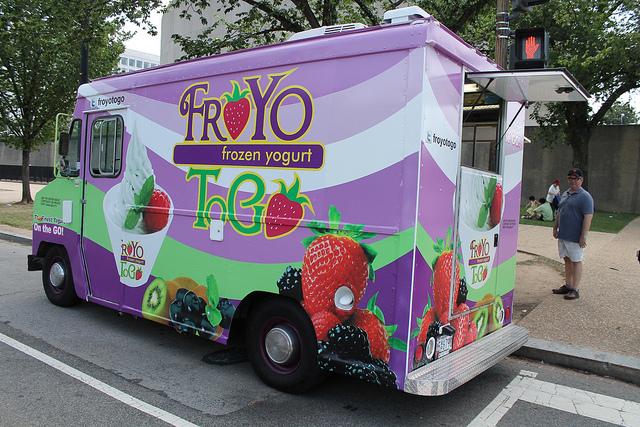Is this an emergency vehicle?
Be succinct. No. What is served here?
Concise answer only. Frozen yogurt. What two berries are pictured on the truck?
Quick response, please. Strawberries and blackberries. What is the name of the food truck?
Short answer required. Froyo. 